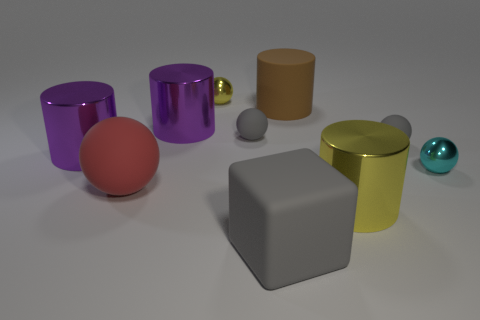What number of other objects are the same color as the large matte cube?
Provide a short and direct response. 2. Does the small gray object on the right side of the brown cylinder have the same material as the block?
Keep it short and to the point. Yes. There is a large gray block in front of the large sphere; what material is it?
Make the answer very short. Rubber. There is a purple metal cylinder on the right side of the big rubber object left of the small yellow metallic object; what is its size?
Give a very brief answer. Large. Are there any other cylinders that have the same material as the big brown cylinder?
Make the answer very short. No. What is the shape of the matte thing in front of the ball that is in front of the small metal thing that is in front of the yellow shiny ball?
Your answer should be very brief. Cube. There is a small metallic ball in front of the yellow ball; is it the same color as the rubber ball in front of the tiny cyan object?
Your response must be concise. No. Are there any other things that have the same size as the red matte thing?
Give a very brief answer. Yes. There is a large brown matte cylinder; are there any large yellow objects in front of it?
Offer a terse response. Yes. What number of large yellow metallic things have the same shape as the brown matte object?
Your response must be concise. 1. 